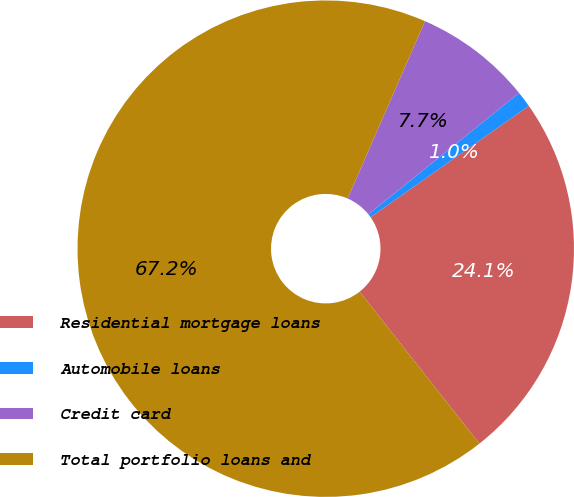Convert chart to OTSL. <chart><loc_0><loc_0><loc_500><loc_500><pie_chart><fcel>Residential mortgage loans<fcel>Automobile loans<fcel>Credit card<fcel>Total portfolio loans and<nl><fcel>24.13%<fcel>1.04%<fcel>7.66%<fcel>67.17%<nl></chart> 